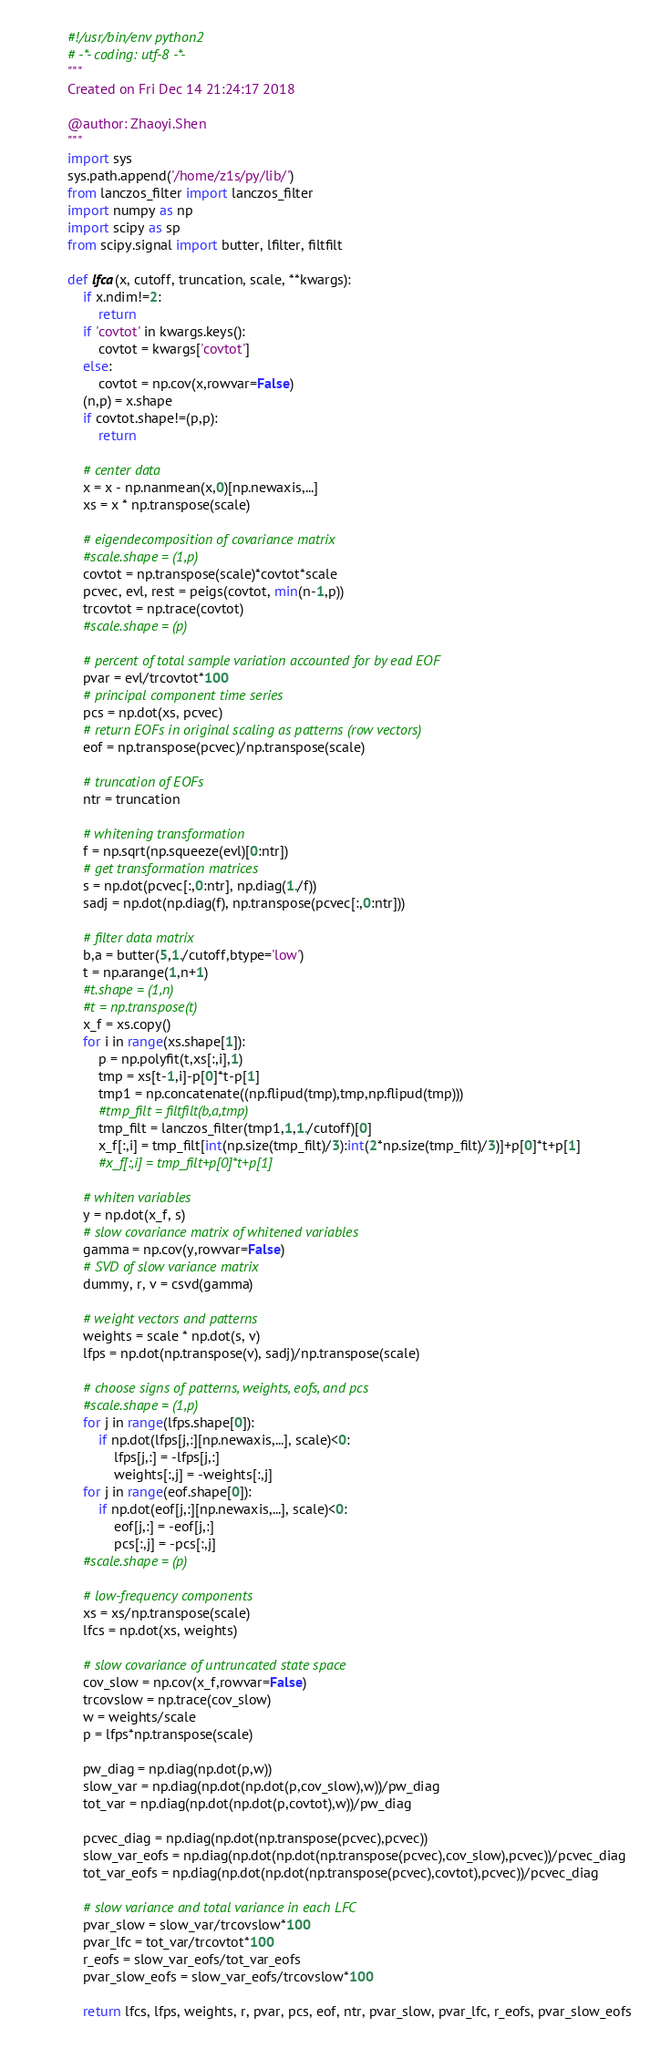<code> <loc_0><loc_0><loc_500><loc_500><_Python_>#!/usr/bin/env python2
# -*- coding: utf-8 -*-
"""
Created on Fri Dec 14 21:24:17 2018

@author: Zhaoyi.Shen
"""
import sys
sys.path.append('/home/z1s/py/lib/')
from lanczos_filter import lanczos_filter
import numpy as np
import scipy as sp
from scipy.signal import butter, lfilter, filtfilt

def lfca(x, cutoff, truncation, scale, **kwargs):
    if x.ndim!=2:
        return
    if 'covtot' in kwargs.keys():
        covtot = kwargs['covtot']
    else:
        covtot = np.cov(x,rowvar=False)
    (n,p) = x.shape
    if covtot.shape!=(p,p):
        return
    
    # center data
    x = x - np.nanmean(x,0)[np.newaxis,...]
    xs = x * np.transpose(scale)
    
    # eigendecomposition of covariance matrix
    #scale.shape = (1,p)
    covtot = np.transpose(scale)*covtot*scale
    pcvec, evl, rest = peigs(covtot, min(n-1,p))
    trcovtot = np.trace(covtot)
    #scale.shape = (p)
    
    # percent of total sample variation accounted for by ead EOF
    pvar = evl/trcovtot*100
    # principal component time series
    pcs = np.dot(xs, pcvec)
    # return EOFs in original scaling as patterns (row vectors)
    eof = np.transpose(pcvec)/np.transpose(scale)
                      
    # truncation of EOFs
    ntr = truncation
    
    # whitening transformation
    f = np.sqrt(np.squeeze(evl)[0:ntr])
    # get transformation matrices
    s = np.dot(pcvec[:,0:ntr], np.diag(1./f))
    sadj = np.dot(np.diag(f), np.transpose(pcvec[:,0:ntr]))
    
    # filter data matrix
    b,a = butter(5,1./cutoff,btype='low')
    t = np.arange(1,n+1)
    #t.shape = (1,n)
    #t = np.transpose(t)
    x_f = xs.copy()
    for i in range(xs.shape[1]):
        p = np.polyfit(t,xs[:,i],1)
        tmp = xs[t-1,i]-p[0]*t-p[1]
        tmp1 = np.concatenate((np.flipud(tmp),tmp,np.flipud(tmp)))
        #tmp_filt = filtfilt(b,a,tmp)
        tmp_filt = lanczos_filter(tmp1,1,1./cutoff)[0]
        x_f[:,i] = tmp_filt[int(np.size(tmp_filt)/3):int(2*np.size(tmp_filt)/3)]+p[0]*t+p[1]
        #x_f[:,i] = tmp_filt+p[0]*t+p[1]
        
    # whiten variables
    y = np.dot(x_f, s)
    # slow covariance matrix of whitened variables
    gamma = np.cov(y,rowvar=False)
    # SVD of slow variance matrix
    dummy, r, v = csvd(gamma)
    
    # weight vectors and patterns
    weights = scale * np.dot(s, v)
    lfps = np.dot(np.transpose(v), sadj)/np.transpose(scale)
                 
    # choose signs of patterns, weights, eofs, and pcs
    #scale.shape = (1,p)
    for j in range(lfps.shape[0]):
        if np.dot(lfps[j,:][np.newaxis,...], scale)<0:
            lfps[j,:] = -lfps[j,:]
            weights[:,j] = -weights[:,j]
    for j in range(eof.shape[0]):
        if np.dot(eof[j,:][np.newaxis,...], scale)<0:
            eof[j,:] = -eof[j,:]
            pcs[:,j] = -pcs[:,j]
    #scale.shape = (p)
            
    # low-frequency components
    xs = xs/np.transpose(scale)
    lfcs = np.dot(xs, weights)
    
    # slow covariance of untruncated state space
    cov_slow = np.cov(x_f,rowvar=False)
    trcovslow = np.trace(cov_slow)
    w = weights/scale
    p = lfps*np.transpose(scale)
    
    pw_diag = np.diag(np.dot(p,w))
    slow_var = np.diag(np.dot(np.dot(p,cov_slow),w))/pw_diag
    tot_var = np.diag(np.dot(np.dot(p,covtot),w))/pw_diag
    
    pcvec_diag = np.diag(np.dot(np.transpose(pcvec),pcvec))
    slow_var_eofs = np.diag(np.dot(np.dot(np.transpose(pcvec),cov_slow),pcvec))/pcvec_diag
    tot_var_eofs = np.diag(np.dot(np.dot(np.transpose(pcvec),covtot),pcvec))/pcvec_diag
                          
    # slow variance and total variance in each LFC
    pvar_slow = slow_var/trcovslow*100
    pvar_lfc = tot_var/trcovtot*100
    r_eofs = slow_var_eofs/tot_var_eofs
    pvar_slow_eofs = slow_var_eofs/trcovslow*100
    
    return lfcs, lfps, weights, r, pvar, pcs, eof, ntr, pvar_slow, pvar_lfc, r_eofs, pvar_slow_eofs
</code> 